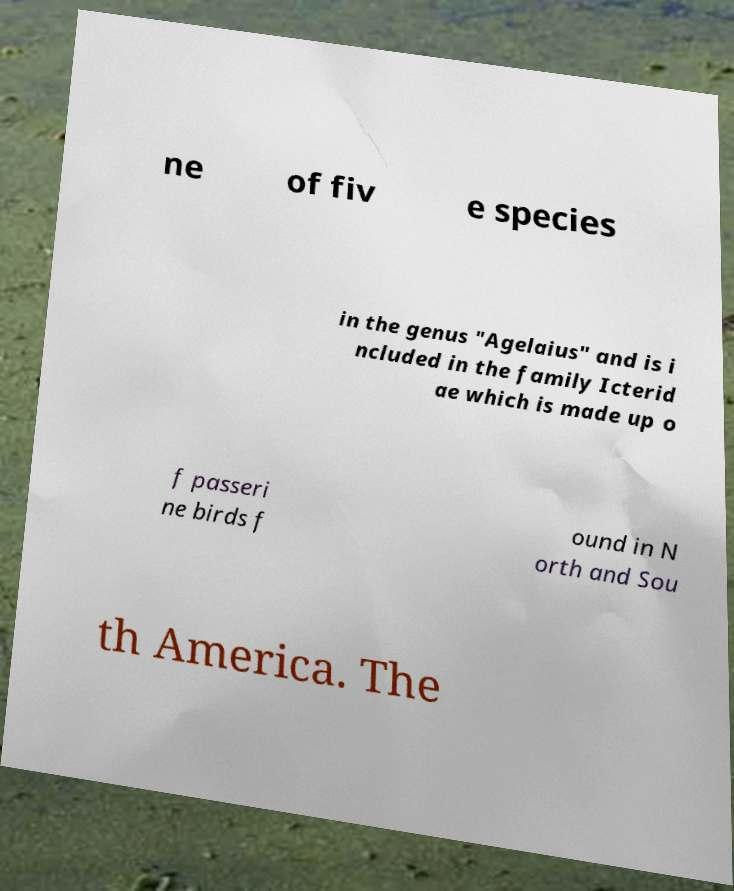I need the written content from this picture converted into text. Can you do that? ne of fiv e species in the genus "Agelaius" and is i ncluded in the family Icterid ae which is made up o f passeri ne birds f ound in N orth and Sou th America. The 